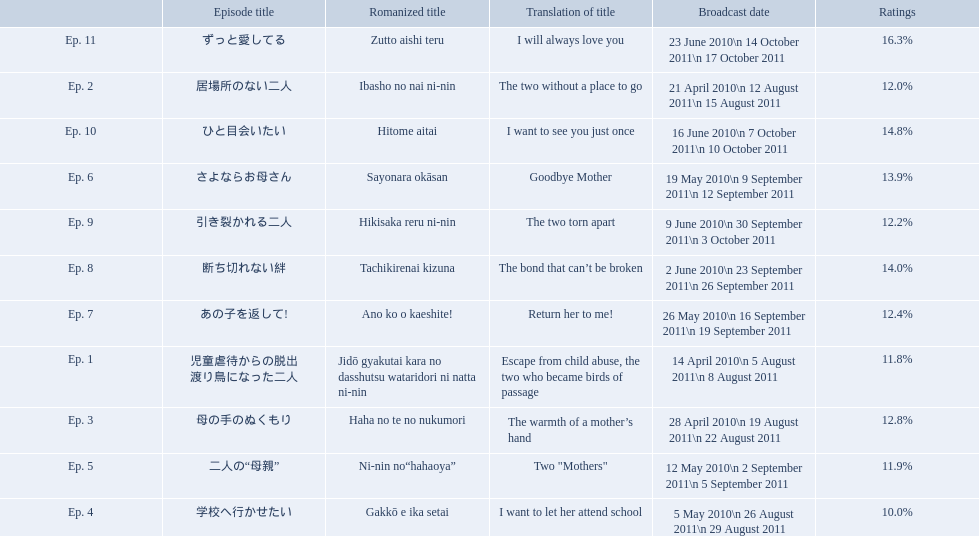What is the name of epsiode 8? 断ち切れない絆. What were this episodes ratings? 14.0%. What are all the episodes? Ep. 1, Ep. 2, Ep. 3, Ep. 4, Ep. 5, Ep. 6, Ep. 7, Ep. 8, Ep. 9, Ep. 10, Ep. 11. Of these, which ones have a rating of 14%? Ep. 8, Ep. 10. Would you be able to parse every entry in this table? {'header': ['', 'Episode title', 'Romanized title', 'Translation of title', 'Broadcast date', 'Ratings'], 'rows': [['Ep. 11', 'ずっと愛してる', 'Zutto aishi teru', 'I will always love you', '23 June 2010\\n 14 October 2011\\n 17 October 2011', '16.3%'], ['Ep. 2', '居場所のない二人', 'Ibasho no nai ni-nin', 'The two without a place to go', '21 April 2010\\n 12 August 2011\\n 15 August 2011', '12.0%'], ['Ep. 10', 'ひと目会いたい', 'Hitome aitai', 'I want to see you just once', '16 June 2010\\n 7 October 2011\\n 10 October 2011', '14.8%'], ['Ep. 6', 'さよならお母さん', 'Sayonara okāsan', 'Goodbye Mother', '19 May 2010\\n 9 September 2011\\n 12 September 2011', '13.9%'], ['Ep. 9', '引き裂かれる二人', 'Hikisaka reru ni-nin', 'The two torn apart', '9 June 2010\\n 30 September 2011\\n 3 October 2011', '12.2%'], ['Ep. 8', '断ち切れない絆', 'Tachikirenai kizuna', 'The bond that can’t be broken', '2 June 2010\\n 23 September 2011\\n 26 September 2011', '14.0%'], ['Ep. 7', 'あの子を返して!', 'Ano ko o kaeshite!', 'Return her to me!', '26 May 2010\\n 16 September 2011\\n 19 September 2011', '12.4%'], ['Ep. 1', '児童虐待からの脱出 渡り鳥になった二人', 'Jidō gyakutai kara no dasshutsu wataridori ni natta ni-nin', 'Escape from child abuse, the two who became birds of passage', '14 April 2010\\n 5 August 2011\\n 8 August 2011', '11.8%'], ['Ep. 3', '母の手のぬくもり', 'Haha no te no nukumori', 'The warmth of a mother’s hand', '28 April 2010\\n 19 August 2011\\n 22 August 2011', '12.8%'], ['Ep. 5', '二人の“母親”', 'Ni-nin no“hahaoya”', 'Two "Mothers"', '12 May 2010\\n 2 September 2011\\n 5 September 2011', '11.9%'], ['Ep. 4', '学校へ行かせたい', 'Gakkō e ika setai', 'I want to let her attend school', '5 May 2010\\n 26 August 2011\\n 29 August 2011', '10.0%']]} Of these, which one is not ep. 10? Ep. 8. 